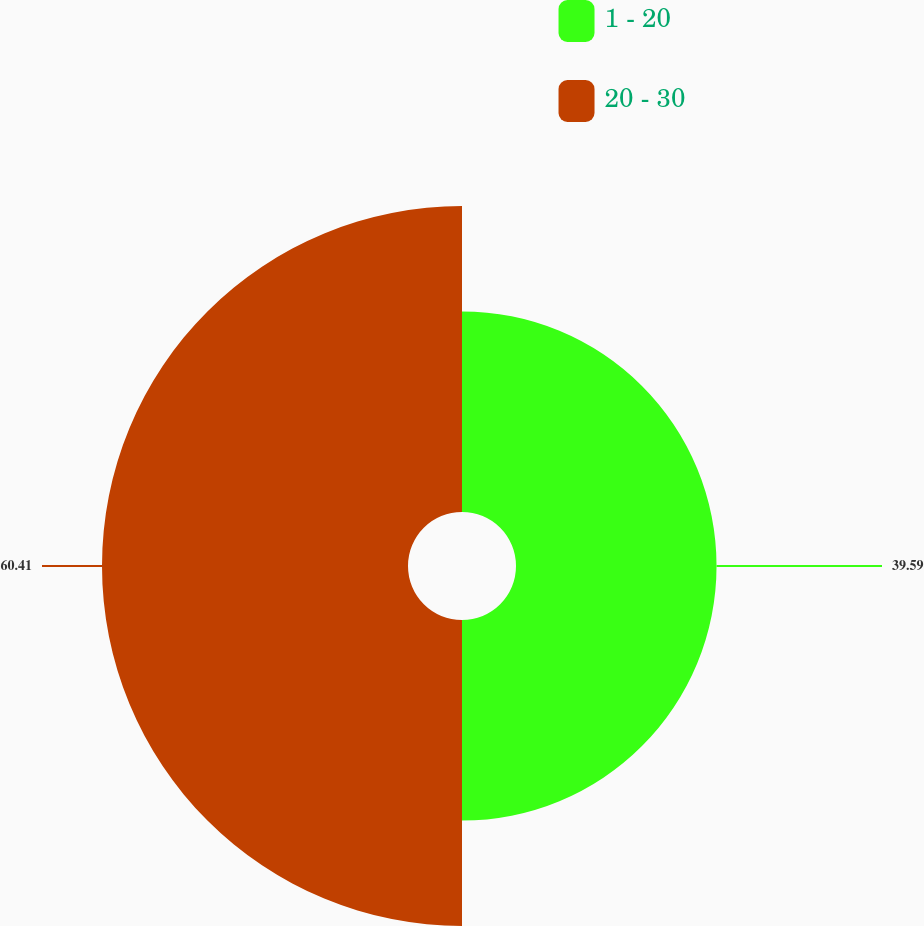Convert chart. <chart><loc_0><loc_0><loc_500><loc_500><pie_chart><fcel>1 - 20<fcel>20 - 30<nl><fcel>39.59%<fcel>60.41%<nl></chart> 